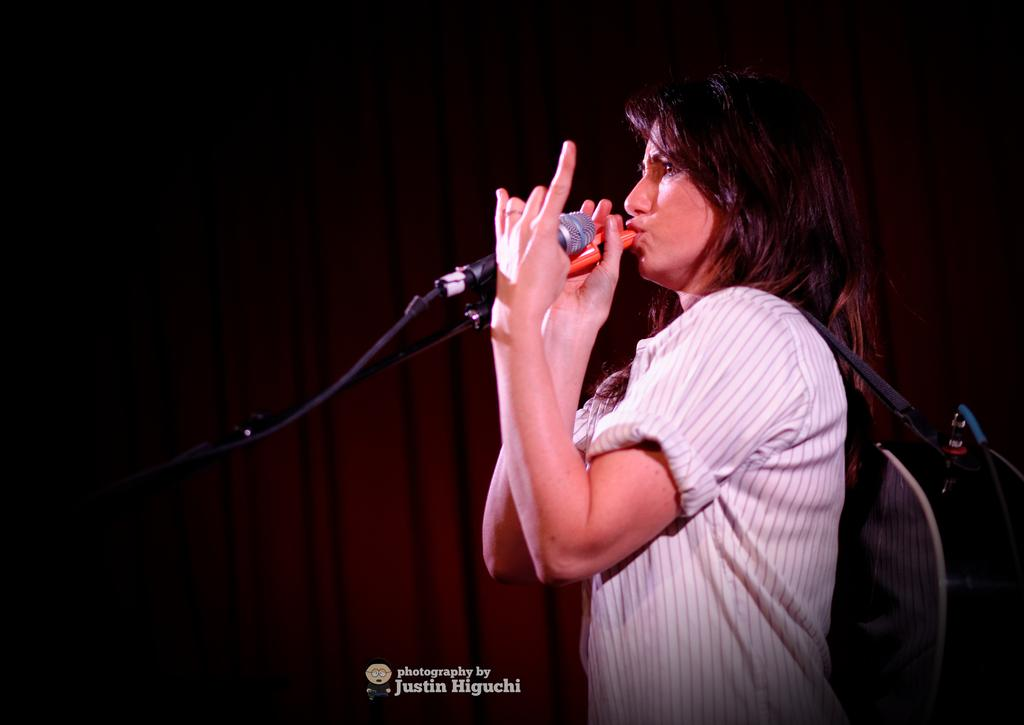Who is the main subject in the image? There is a woman in the image. Where is the woman positioned in the image? The woman is towards the right side of the image. What is the woman wearing? The woman is wearing a striped shirt. What is the woman holding in the image? The woman is holding a microphone. What other item is the woman carrying in the image? The woman is carrying a guitar. What can be seen in the background of the image? There is a curtain in the background of the image. What type of spoon is the woman using to play the guitar in the image? There is no spoon present in the image, and the woman is not using a spoon to play the guitar. 